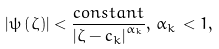Convert formula to latex. <formula><loc_0><loc_0><loc_500><loc_500>\left | \psi \left ( \zeta \right ) \right | < \frac { c o n s t a n t } { \left | \zeta - c _ { k } \right | ^ { \alpha _ { k } } } , \, \alpha _ { k } \, < 1 ,</formula> 